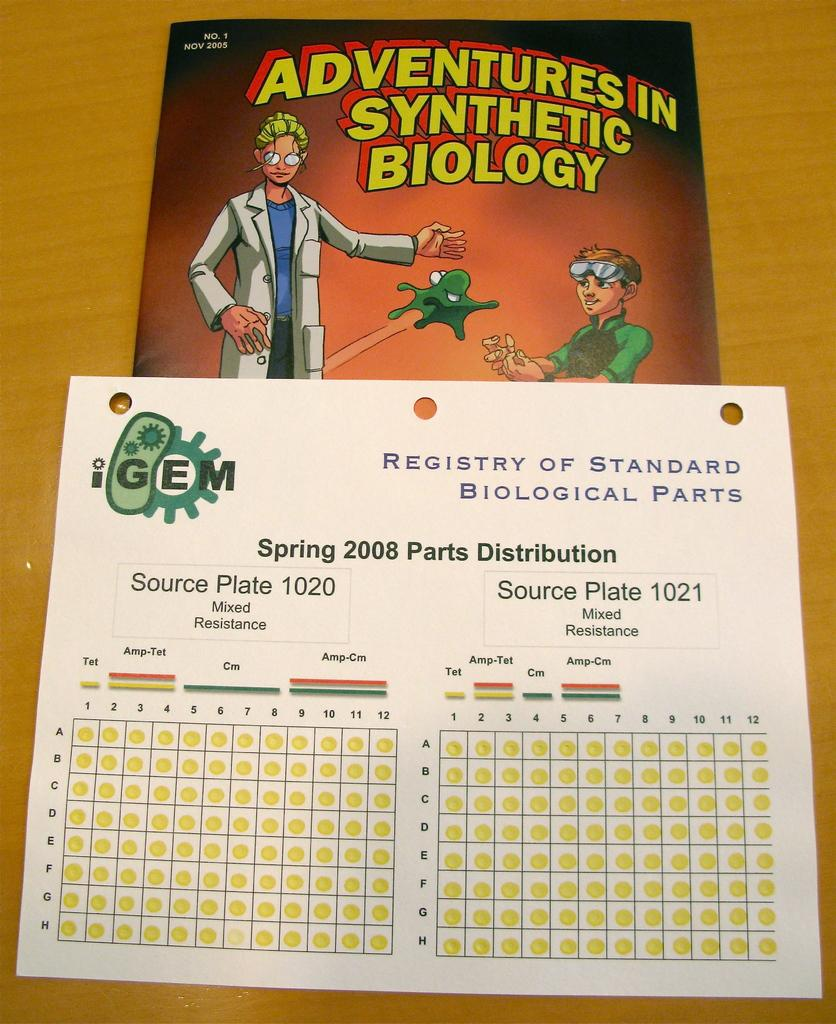<image>
Give a short and clear explanation of the subsequent image. A book about Adventures in Synthetic Biology was released in Nov 2005 